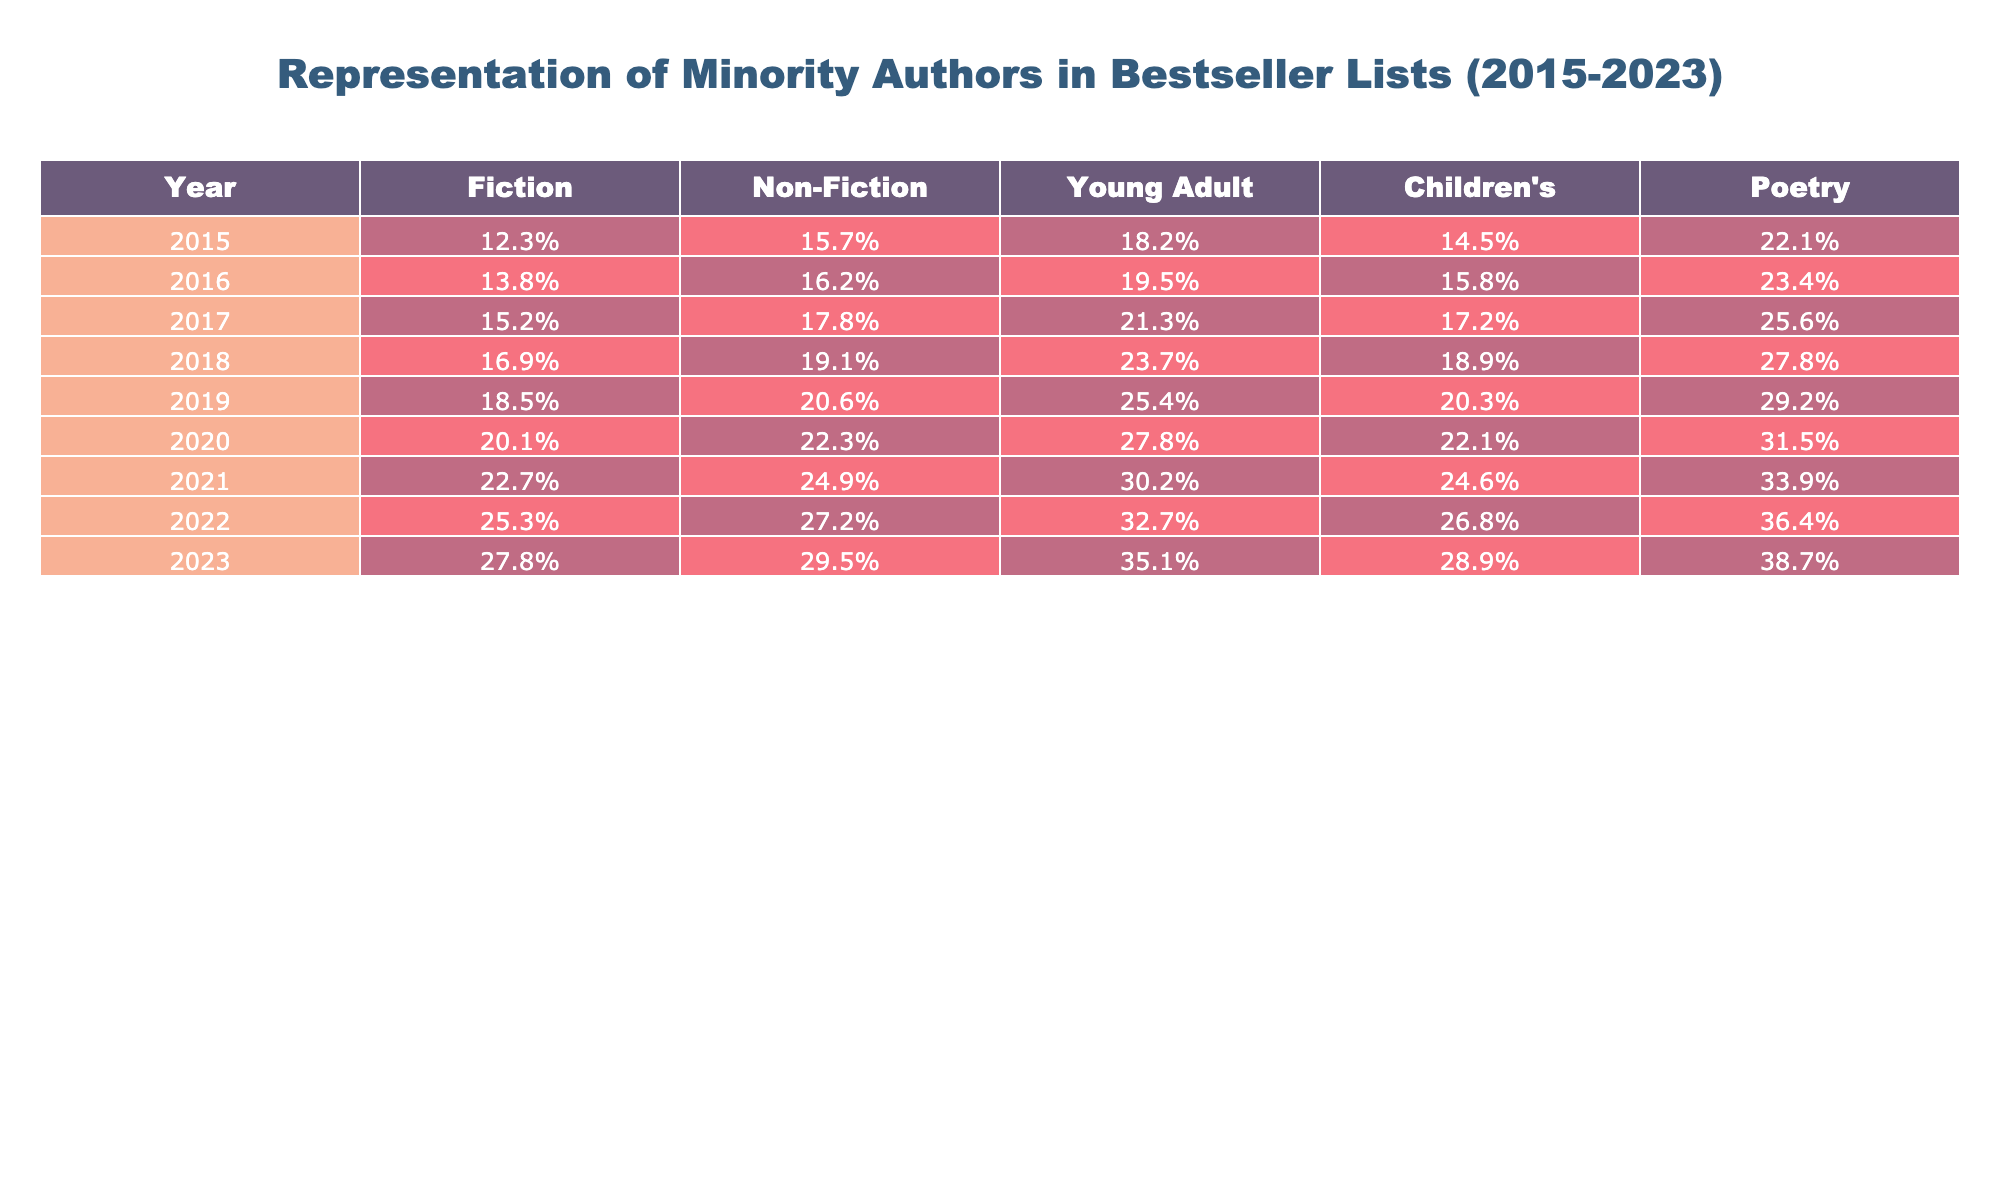What was the percentage of minority authors in Fiction in 2015? In the table, the value for the Fiction column in the year 2015 is 12.3%. This is a specific retrieval question asking for a direct value.
Answer: 12.3% Which category had the highest representation of minority authors in 2023? Looking across the columns in the year 2023, the Poetry category holds the highest percentage at 38.7%. This can be determined by comparing all the values in that year.
Answer: Poetry What is the difference in representation of minority authors between Non-Fiction in 2020 and 2023? The percentage for Non-Fiction in 2023 is 29.5% and in 2020 is 22.3%. The difference is calculated as 29.5% - 22.3% = 7.2%.
Answer: 7.2% What was the average percentage of minority authors across all categories in 2019? The percentages for 2019 in all categories are: Fiction (18.5%), Non-Fiction (20.6%), Young Adult (25.4%), Children's (20.3%), and Poetry (29.2%). The total sum is 18.5 + 20.6 + 25.4 + 20.3 + 29.2 = 114.0%. Dividing by the number of categories (5), the average is 114.0% / 5 = 22.8%.
Answer: 22.8% Is there a trend of increasing representation of minority authors in Young Adult books from 2015 to 2023? By examining the percentages in the Young Adult category from 2015 (18.2%) to 2023 (35.1%), it is clear there is a consistent increase each year, indicating a positive trend. This assesses the data over time.
Answer: Yes What was the percentage increase in representation for the Children's category between 2015 and 2022? The percentage for Children's in 2015 is 14.5% and in 2022 is 26.8%. The increase is calculated as 26.8% - 14.5% = 12.3%. This compares values from two different years.
Answer: 12.3% Which year saw the lowest percentage of minority authors in Non-Fiction? The Non-Fiction percentages from 2015 to 2023 are 15.7%, 16.2%, 17.8%, 19.1%, 20.6%, 22.3%, 24.9%, 27.2%, and 29.5%. The lowest among these is in 2015, at 15.7%. This requires scanning the data for the minimum value.
Answer: 2015 If the trend continues, what would be the expected percentage for Fiction in 2024 based on previous years' data? To estimate the 2024 percentage for Fiction, we calculate the average increase from 2015 to 2023, which is about 2.5% per year (from 12.3% to 27.8% over 9 years). Adding this to the 2023 figure gives 27.8% + 2.5% = 30.3%. This includes calculating the rate of increase.
Answer: 30.3% 